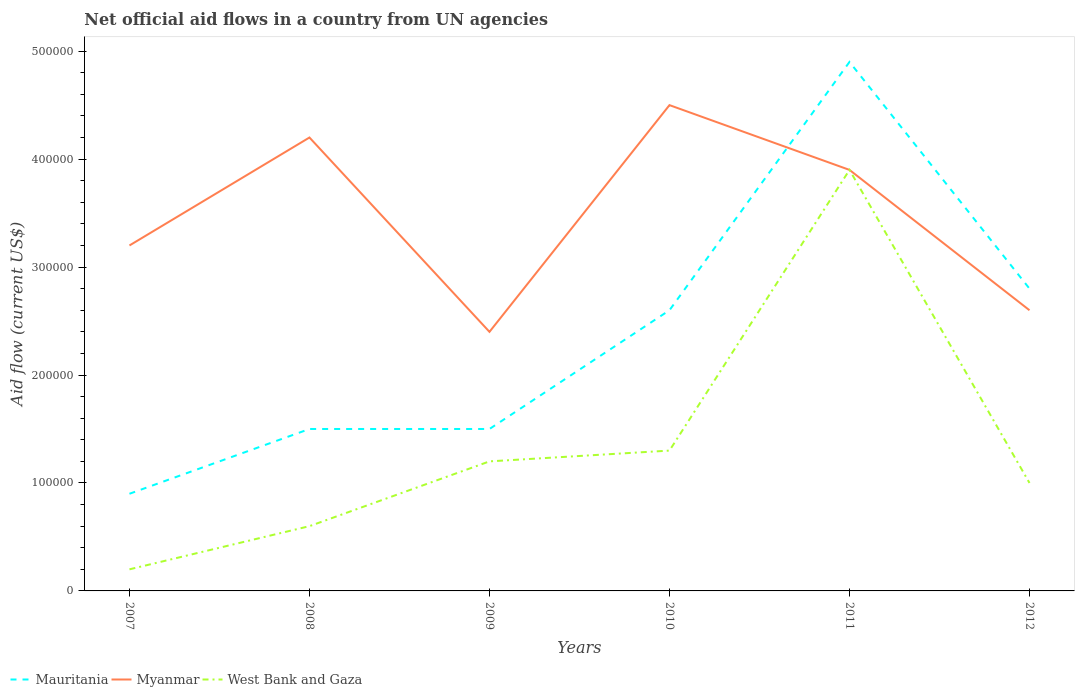Is the number of lines equal to the number of legend labels?
Give a very brief answer. Yes. What is the total net official aid flow in West Bank and Gaza in the graph?
Keep it short and to the point. -1.10e+05. What is the difference between the highest and the second highest net official aid flow in Myanmar?
Provide a succinct answer. 2.10e+05. Is the net official aid flow in Myanmar strictly greater than the net official aid flow in West Bank and Gaza over the years?
Your response must be concise. No. How many years are there in the graph?
Provide a succinct answer. 6. What is the difference between two consecutive major ticks on the Y-axis?
Your response must be concise. 1.00e+05. Are the values on the major ticks of Y-axis written in scientific E-notation?
Your answer should be very brief. No. Does the graph contain any zero values?
Keep it short and to the point. No. Where does the legend appear in the graph?
Provide a succinct answer. Bottom left. How are the legend labels stacked?
Make the answer very short. Horizontal. What is the title of the graph?
Provide a succinct answer. Net official aid flows in a country from UN agencies. What is the Aid flow (current US$) of Myanmar in 2007?
Offer a very short reply. 3.20e+05. What is the Aid flow (current US$) of Mauritania in 2008?
Offer a terse response. 1.50e+05. What is the Aid flow (current US$) of West Bank and Gaza in 2008?
Your answer should be very brief. 6.00e+04. What is the Aid flow (current US$) in Mauritania in 2009?
Keep it short and to the point. 1.50e+05. What is the Aid flow (current US$) in Mauritania in 2010?
Offer a very short reply. 2.60e+05. What is the Aid flow (current US$) in West Bank and Gaza in 2010?
Give a very brief answer. 1.30e+05. What is the Aid flow (current US$) in Myanmar in 2011?
Offer a very short reply. 3.90e+05. What is the Aid flow (current US$) of West Bank and Gaza in 2011?
Offer a very short reply. 3.90e+05. What is the Aid flow (current US$) in Mauritania in 2012?
Offer a terse response. 2.80e+05. What is the Aid flow (current US$) of West Bank and Gaza in 2012?
Make the answer very short. 1.00e+05. Across all years, what is the maximum Aid flow (current US$) of Myanmar?
Offer a very short reply. 4.50e+05. Across all years, what is the minimum Aid flow (current US$) of Mauritania?
Your response must be concise. 9.00e+04. Across all years, what is the minimum Aid flow (current US$) of Myanmar?
Provide a succinct answer. 2.40e+05. Across all years, what is the minimum Aid flow (current US$) of West Bank and Gaza?
Your answer should be very brief. 2.00e+04. What is the total Aid flow (current US$) of Mauritania in the graph?
Your answer should be very brief. 1.42e+06. What is the total Aid flow (current US$) of Myanmar in the graph?
Keep it short and to the point. 2.08e+06. What is the total Aid flow (current US$) of West Bank and Gaza in the graph?
Your answer should be compact. 8.20e+05. What is the difference between the Aid flow (current US$) of Myanmar in 2007 and that in 2008?
Ensure brevity in your answer.  -1.00e+05. What is the difference between the Aid flow (current US$) in West Bank and Gaza in 2007 and that in 2008?
Make the answer very short. -4.00e+04. What is the difference between the Aid flow (current US$) of Mauritania in 2007 and that in 2009?
Give a very brief answer. -6.00e+04. What is the difference between the Aid flow (current US$) of West Bank and Gaza in 2007 and that in 2009?
Provide a short and direct response. -1.00e+05. What is the difference between the Aid flow (current US$) in West Bank and Gaza in 2007 and that in 2010?
Provide a short and direct response. -1.10e+05. What is the difference between the Aid flow (current US$) in Mauritania in 2007 and that in 2011?
Ensure brevity in your answer.  -4.00e+05. What is the difference between the Aid flow (current US$) in West Bank and Gaza in 2007 and that in 2011?
Offer a very short reply. -3.70e+05. What is the difference between the Aid flow (current US$) in Myanmar in 2007 and that in 2012?
Keep it short and to the point. 6.00e+04. What is the difference between the Aid flow (current US$) of West Bank and Gaza in 2007 and that in 2012?
Give a very brief answer. -8.00e+04. What is the difference between the Aid flow (current US$) in West Bank and Gaza in 2008 and that in 2009?
Your answer should be very brief. -6.00e+04. What is the difference between the Aid flow (current US$) in Mauritania in 2008 and that in 2010?
Your answer should be compact. -1.10e+05. What is the difference between the Aid flow (current US$) of Myanmar in 2008 and that in 2010?
Ensure brevity in your answer.  -3.00e+04. What is the difference between the Aid flow (current US$) in Mauritania in 2008 and that in 2011?
Keep it short and to the point. -3.40e+05. What is the difference between the Aid flow (current US$) in West Bank and Gaza in 2008 and that in 2011?
Offer a terse response. -3.30e+05. What is the difference between the Aid flow (current US$) of Mauritania in 2009 and that in 2010?
Your answer should be very brief. -1.10e+05. What is the difference between the Aid flow (current US$) in Myanmar in 2009 and that in 2010?
Provide a succinct answer. -2.10e+05. What is the difference between the Aid flow (current US$) in West Bank and Gaza in 2009 and that in 2010?
Your answer should be very brief. -10000. What is the difference between the Aid flow (current US$) in Myanmar in 2009 and that in 2011?
Give a very brief answer. -1.50e+05. What is the difference between the Aid flow (current US$) of West Bank and Gaza in 2009 and that in 2011?
Your answer should be compact. -2.70e+05. What is the difference between the Aid flow (current US$) in Mauritania in 2010 and that in 2011?
Your response must be concise. -2.30e+05. What is the difference between the Aid flow (current US$) in Mauritania in 2010 and that in 2012?
Provide a short and direct response. -2.00e+04. What is the difference between the Aid flow (current US$) in Myanmar in 2010 and that in 2012?
Offer a very short reply. 1.90e+05. What is the difference between the Aid flow (current US$) of Mauritania in 2011 and that in 2012?
Your answer should be very brief. 2.10e+05. What is the difference between the Aid flow (current US$) in Myanmar in 2011 and that in 2012?
Keep it short and to the point. 1.30e+05. What is the difference between the Aid flow (current US$) of West Bank and Gaza in 2011 and that in 2012?
Your answer should be compact. 2.90e+05. What is the difference between the Aid flow (current US$) in Mauritania in 2007 and the Aid flow (current US$) in Myanmar in 2008?
Your response must be concise. -3.30e+05. What is the difference between the Aid flow (current US$) in Myanmar in 2007 and the Aid flow (current US$) in West Bank and Gaza in 2008?
Ensure brevity in your answer.  2.60e+05. What is the difference between the Aid flow (current US$) of Mauritania in 2007 and the Aid flow (current US$) of Myanmar in 2009?
Your answer should be compact. -1.50e+05. What is the difference between the Aid flow (current US$) of Myanmar in 2007 and the Aid flow (current US$) of West Bank and Gaza in 2009?
Provide a short and direct response. 2.00e+05. What is the difference between the Aid flow (current US$) in Mauritania in 2007 and the Aid flow (current US$) in Myanmar in 2010?
Provide a succinct answer. -3.60e+05. What is the difference between the Aid flow (current US$) in Mauritania in 2007 and the Aid flow (current US$) in West Bank and Gaza in 2010?
Give a very brief answer. -4.00e+04. What is the difference between the Aid flow (current US$) of Mauritania in 2007 and the Aid flow (current US$) of Myanmar in 2011?
Offer a very short reply. -3.00e+05. What is the difference between the Aid flow (current US$) of Myanmar in 2007 and the Aid flow (current US$) of West Bank and Gaza in 2011?
Give a very brief answer. -7.00e+04. What is the difference between the Aid flow (current US$) of Mauritania in 2007 and the Aid flow (current US$) of Myanmar in 2012?
Your answer should be compact. -1.70e+05. What is the difference between the Aid flow (current US$) in Mauritania in 2007 and the Aid flow (current US$) in West Bank and Gaza in 2012?
Keep it short and to the point. -10000. What is the difference between the Aid flow (current US$) of Myanmar in 2007 and the Aid flow (current US$) of West Bank and Gaza in 2012?
Give a very brief answer. 2.20e+05. What is the difference between the Aid flow (current US$) of Mauritania in 2008 and the Aid flow (current US$) of West Bank and Gaza in 2009?
Offer a very short reply. 3.00e+04. What is the difference between the Aid flow (current US$) in Mauritania in 2008 and the Aid flow (current US$) in Myanmar in 2011?
Your response must be concise. -2.40e+05. What is the difference between the Aid flow (current US$) in Mauritania in 2008 and the Aid flow (current US$) in West Bank and Gaza in 2011?
Your answer should be compact. -2.40e+05. What is the difference between the Aid flow (current US$) in Myanmar in 2008 and the Aid flow (current US$) in West Bank and Gaza in 2011?
Your response must be concise. 3.00e+04. What is the difference between the Aid flow (current US$) in Mauritania in 2008 and the Aid flow (current US$) in West Bank and Gaza in 2012?
Offer a very short reply. 5.00e+04. What is the difference between the Aid flow (current US$) in Myanmar in 2008 and the Aid flow (current US$) in West Bank and Gaza in 2012?
Provide a short and direct response. 3.20e+05. What is the difference between the Aid flow (current US$) in Mauritania in 2009 and the Aid flow (current US$) in West Bank and Gaza in 2011?
Make the answer very short. -2.40e+05. What is the difference between the Aid flow (current US$) of Myanmar in 2009 and the Aid flow (current US$) of West Bank and Gaza in 2011?
Offer a very short reply. -1.50e+05. What is the difference between the Aid flow (current US$) in Mauritania in 2009 and the Aid flow (current US$) in Myanmar in 2012?
Ensure brevity in your answer.  -1.10e+05. What is the difference between the Aid flow (current US$) in Mauritania in 2009 and the Aid flow (current US$) in West Bank and Gaza in 2012?
Offer a terse response. 5.00e+04. What is the difference between the Aid flow (current US$) in Myanmar in 2009 and the Aid flow (current US$) in West Bank and Gaza in 2012?
Your answer should be compact. 1.40e+05. What is the difference between the Aid flow (current US$) in Mauritania in 2010 and the Aid flow (current US$) in West Bank and Gaza in 2011?
Your response must be concise. -1.30e+05. What is the difference between the Aid flow (current US$) of Myanmar in 2010 and the Aid flow (current US$) of West Bank and Gaza in 2011?
Keep it short and to the point. 6.00e+04. What is the difference between the Aid flow (current US$) of Mauritania in 2010 and the Aid flow (current US$) of West Bank and Gaza in 2012?
Your answer should be compact. 1.60e+05. What is the difference between the Aid flow (current US$) in Myanmar in 2010 and the Aid flow (current US$) in West Bank and Gaza in 2012?
Your answer should be very brief. 3.50e+05. What is the difference between the Aid flow (current US$) in Mauritania in 2011 and the Aid flow (current US$) in Myanmar in 2012?
Offer a very short reply. 2.30e+05. What is the difference between the Aid flow (current US$) of Mauritania in 2011 and the Aid flow (current US$) of West Bank and Gaza in 2012?
Provide a succinct answer. 3.90e+05. What is the average Aid flow (current US$) in Mauritania per year?
Your answer should be compact. 2.37e+05. What is the average Aid flow (current US$) of Myanmar per year?
Provide a succinct answer. 3.47e+05. What is the average Aid flow (current US$) in West Bank and Gaza per year?
Ensure brevity in your answer.  1.37e+05. In the year 2007, what is the difference between the Aid flow (current US$) in Mauritania and Aid flow (current US$) in Myanmar?
Make the answer very short. -2.30e+05. In the year 2007, what is the difference between the Aid flow (current US$) of Mauritania and Aid flow (current US$) of West Bank and Gaza?
Keep it short and to the point. 7.00e+04. In the year 2007, what is the difference between the Aid flow (current US$) in Myanmar and Aid flow (current US$) in West Bank and Gaza?
Provide a short and direct response. 3.00e+05. In the year 2008, what is the difference between the Aid flow (current US$) of Mauritania and Aid flow (current US$) of West Bank and Gaza?
Give a very brief answer. 9.00e+04. In the year 2009, what is the difference between the Aid flow (current US$) of Mauritania and Aid flow (current US$) of Myanmar?
Give a very brief answer. -9.00e+04. In the year 2009, what is the difference between the Aid flow (current US$) of Mauritania and Aid flow (current US$) of West Bank and Gaza?
Give a very brief answer. 3.00e+04. In the year 2009, what is the difference between the Aid flow (current US$) of Myanmar and Aid flow (current US$) of West Bank and Gaza?
Provide a short and direct response. 1.20e+05. In the year 2010, what is the difference between the Aid flow (current US$) of Myanmar and Aid flow (current US$) of West Bank and Gaza?
Offer a terse response. 3.20e+05. In the year 2011, what is the difference between the Aid flow (current US$) of Mauritania and Aid flow (current US$) of Myanmar?
Ensure brevity in your answer.  1.00e+05. In the year 2011, what is the difference between the Aid flow (current US$) of Mauritania and Aid flow (current US$) of West Bank and Gaza?
Provide a succinct answer. 1.00e+05. In the year 2011, what is the difference between the Aid flow (current US$) of Myanmar and Aid flow (current US$) of West Bank and Gaza?
Offer a very short reply. 0. In the year 2012, what is the difference between the Aid flow (current US$) in Mauritania and Aid flow (current US$) in Myanmar?
Provide a short and direct response. 2.00e+04. In the year 2012, what is the difference between the Aid flow (current US$) in Mauritania and Aid flow (current US$) in West Bank and Gaza?
Provide a succinct answer. 1.80e+05. In the year 2012, what is the difference between the Aid flow (current US$) in Myanmar and Aid flow (current US$) in West Bank and Gaza?
Ensure brevity in your answer.  1.60e+05. What is the ratio of the Aid flow (current US$) of Myanmar in 2007 to that in 2008?
Your answer should be compact. 0.76. What is the ratio of the Aid flow (current US$) of West Bank and Gaza in 2007 to that in 2008?
Provide a short and direct response. 0.33. What is the ratio of the Aid flow (current US$) in West Bank and Gaza in 2007 to that in 2009?
Offer a terse response. 0.17. What is the ratio of the Aid flow (current US$) in Mauritania in 2007 to that in 2010?
Ensure brevity in your answer.  0.35. What is the ratio of the Aid flow (current US$) in Myanmar in 2007 to that in 2010?
Your answer should be very brief. 0.71. What is the ratio of the Aid flow (current US$) in West Bank and Gaza in 2007 to that in 2010?
Your response must be concise. 0.15. What is the ratio of the Aid flow (current US$) of Mauritania in 2007 to that in 2011?
Keep it short and to the point. 0.18. What is the ratio of the Aid flow (current US$) of Myanmar in 2007 to that in 2011?
Your answer should be compact. 0.82. What is the ratio of the Aid flow (current US$) of West Bank and Gaza in 2007 to that in 2011?
Your response must be concise. 0.05. What is the ratio of the Aid flow (current US$) of Mauritania in 2007 to that in 2012?
Provide a succinct answer. 0.32. What is the ratio of the Aid flow (current US$) of Myanmar in 2007 to that in 2012?
Your answer should be compact. 1.23. What is the ratio of the Aid flow (current US$) in West Bank and Gaza in 2008 to that in 2009?
Ensure brevity in your answer.  0.5. What is the ratio of the Aid flow (current US$) in Mauritania in 2008 to that in 2010?
Keep it short and to the point. 0.58. What is the ratio of the Aid flow (current US$) in Myanmar in 2008 to that in 2010?
Your response must be concise. 0.93. What is the ratio of the Aid flow (current US$) in West Bank and Gaza in 2008 to that in 2010?
Ensure brevity in your answer.  0.46. What is the ratio of the Aid flow (current US$) of Mauritania in 2008 to that in 2011?
Ensure brevity in your answer.  0.31. What is the ratio of the Aid flow (current US$) of West Bank and Gaza in 2008 to that in 2011?
Provide a succinct answer. 0.15. What is the ratio of the Aid flow (current US$) of Mauritania in 2008 to that in 2012?
Give a very brief answer. 0.54. What is the ratio of the Aid flow (current US$) in Myanmar in 2008 to that in 2012?
Offer a terse response. 1.62. What is the ratio of the Aid flow (current US$) of West Bank and Gaza in 2008 to that in 2012?
Offer a terse response. 0.6. What is the ratio of the Aid flow (current US$) of Mauritania in 2009 to that in 2010?
Provide a short and direct response. 0.58. What is the ratio of the Aid flow (current US$) of Myanmar in 2009 to that in 2010?
Make the answer very short. 0.53. What is the ratio of the Aid flow (current US$) of West Bank and Gaza in 2009 to that in 2010?
Make the answer very short. 0.92. What is the ratio of the Aid flow (current US$) of Mauritania in 2009 to that in 2011?
Your answer should be very brief. 0.31. What is the ratio of the Aid flow (current US$) in Myanmar in 2009 to that in 2011?
Keep it short and to the point. 0.62. What is the ratio of the Aid flow (current US$) of West Bank and Gaza in 2009 to that in 2011?
Offer a terse response. 0.31. What is the ratio of the Aid flow (current US$) of Mauritania in 2009 to that in 2012?
Your answer should be very brief. 0.54. What is the ratio of the Aid flow (current US$) in Mauritania in 2010 to that in 2011?
Give a very brief answer. 0.53. What is the ratio of the Aid flow (current US$) of Myanmar in 2010 to that in 2011?
Give a very brief answer. 1.15. What is the ratio of the Aid flow (current US$) in Mauritania in 2010 to that in 2012?
Provide a succinct answer. 0.93. What is the ratio of the Aid flow (current US$) in Myanmar in 2010 to that in 2012?
Your answer should be compact. 1.73. What is the ratio of the Aid flow (current US$) in West Bank and Gaza in 2010 to that in 2012?
Provide a short and direct response. 1.3. What is the ratio of the Aid flow (current US$) in Mauritania in 2011 to that in 2012?
Offer a very short reply. 1.75. What is the ratio of the Aid flow (current US$) in Myanmar in 2011 to that in 2012?
Offer a terse response. 1.5. What is the difference between the highest and the second highest Aid flow (current US$) of Mauritania?
Your answer should be very brief. 2.10e+05. What is the difference between the highest and the second highest Aid flow (current US$) of West Bank and Gaza?
Offer a terse response. 2.60e+05. What is the difference between the highest and the lowest Aid flow (current US$) in Myanmar?
Your response must be concise. 2.10e+05. What is the difference between the highest and the lowest Aid flow (current US$) of West Bank and Gaza?
Your answer should be compact. 3.70e+05. 